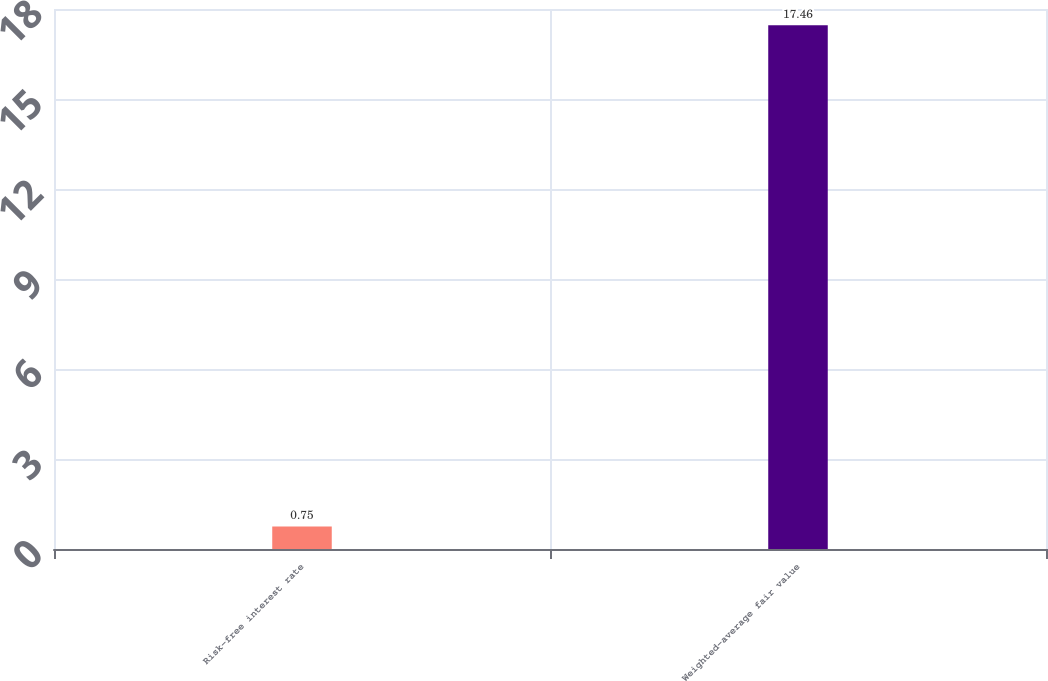<chart> <loc_0><loc_0><loc_500><loc_500><bar_chart><fcel>Risk-free interest rate<fcel>Weighted-average fair value<nl><fcel>0.75<fcel>17.46<nl></chart> 